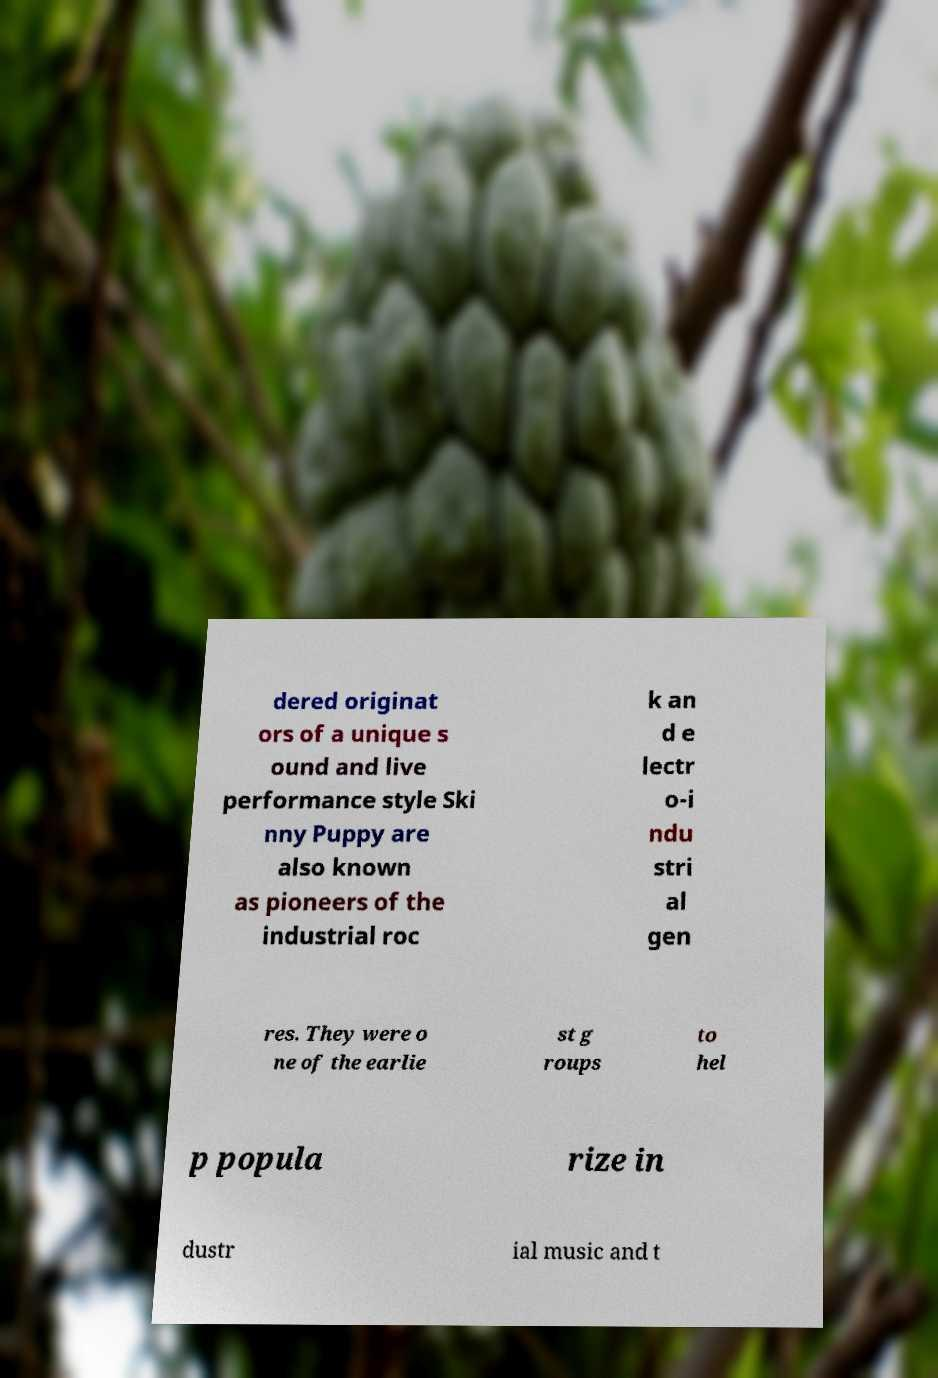Please identify and transcribe the text found in this image. dered originat ors of a unique s ound and live performance style Ski nny Puppy are also known as pioneers of the industrial roc k an d e lectr o-i ndu stri al gen res. They were o ne of the earlie st g roups to hel p popula rize in dustr ial music and t 